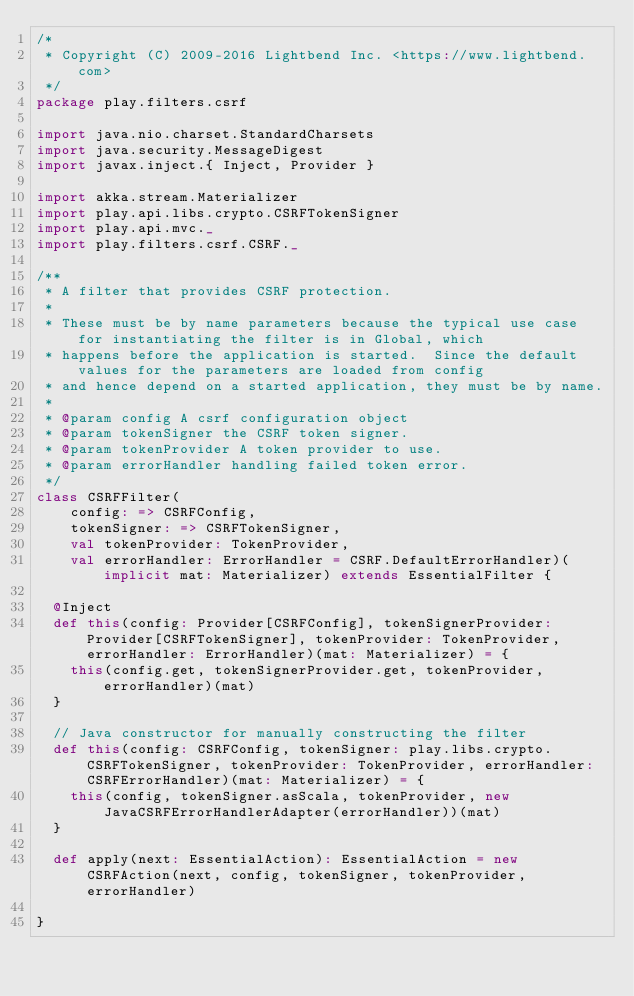<code> <loc_0><loc_0><loc_500><loc_500><_Scala_>/*
 * Copyright (C) 2009-2016 Lightbend Inc. <https://www.lightbend.com>
 */
package play.filters.csrf

import java.nio.charset.StandardCharsets
import java.security.MessageDigest
import javax.inject.{ Inject, Provider }

import akka.stream.Materializer
import play.api.libs.crypto.CSRFTokenSigner
import play.api.mvc._
import play.filters.csrf.CSRF._

/**
 * A filter that provides CSRF protection.
 *
 * These must be by name parameters because the typical use case for instantiating the filter is in Global, which
 * happens before the application is started.  Since the default values for the parameters are loaded from config
 * and hence depend on a started application, they must be by name.
 *
 * @param config A csrf configuration object
 * @param tokenSigner the CSRF token signer.
 * @param tokenProvider A token provider to use.
 * @param errorHandler handling failed token error.
 */
class CSRFFilter(
    config: => CSRFConfig,
    tokenSigner: => CSRFTokenSigner,
    val tokenProvider: TokenProvider,
    val errorHandler: ErrorHandler = CSRF.DefaultErrorHandler)(implicit mat: Materializer) extends EssentialFilter {

  @Inject
  def this(config: Provider[CSRFConfig], tokenSignerProvider: Provider[CSRFTokenSigner], tokenProvider: TokenProvider, errorHandler: ErrorHandler)(mat: Materializer) = {
    this(config.get, tokenSignerProvider.get, tokenProvider, errorHandler)(mat)
  }

  // Java constructor for manually constructing the filter
  def this(config: CSRFConfig, tokenSigner: play.libs.crypto.CSRFTokenSigner, tokenProvider: TokenProvider, errorHandler: CSRFErrorHandler)(mat: Materializer) = {
    this(config, tokenSigner.asScala, tokenProvider, new JavaCSRFErrorHandlerAdapter(errorHandler))(mat)
  }

  def apply(next: EssentialAction): EssentialAction = new CSRFAction(next, config, tokenSigner, tokenProvider, errorHandler)

}
</code> 